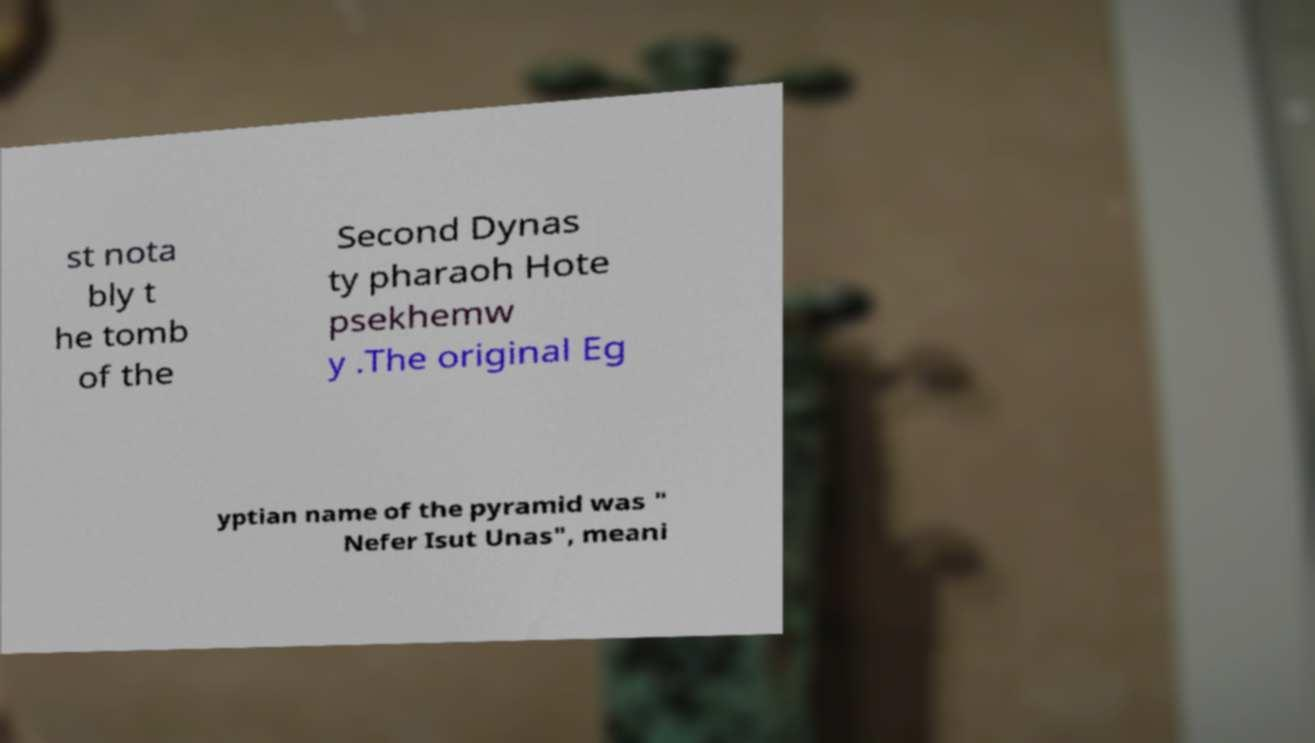Could you extract and type out the text from this image? st nota bly t he tomb of the Second Dynas ty pharaoh Hote psekhemw y .The original Eg yptian name of the pyramid was " Nefer Isut Unas", meani 